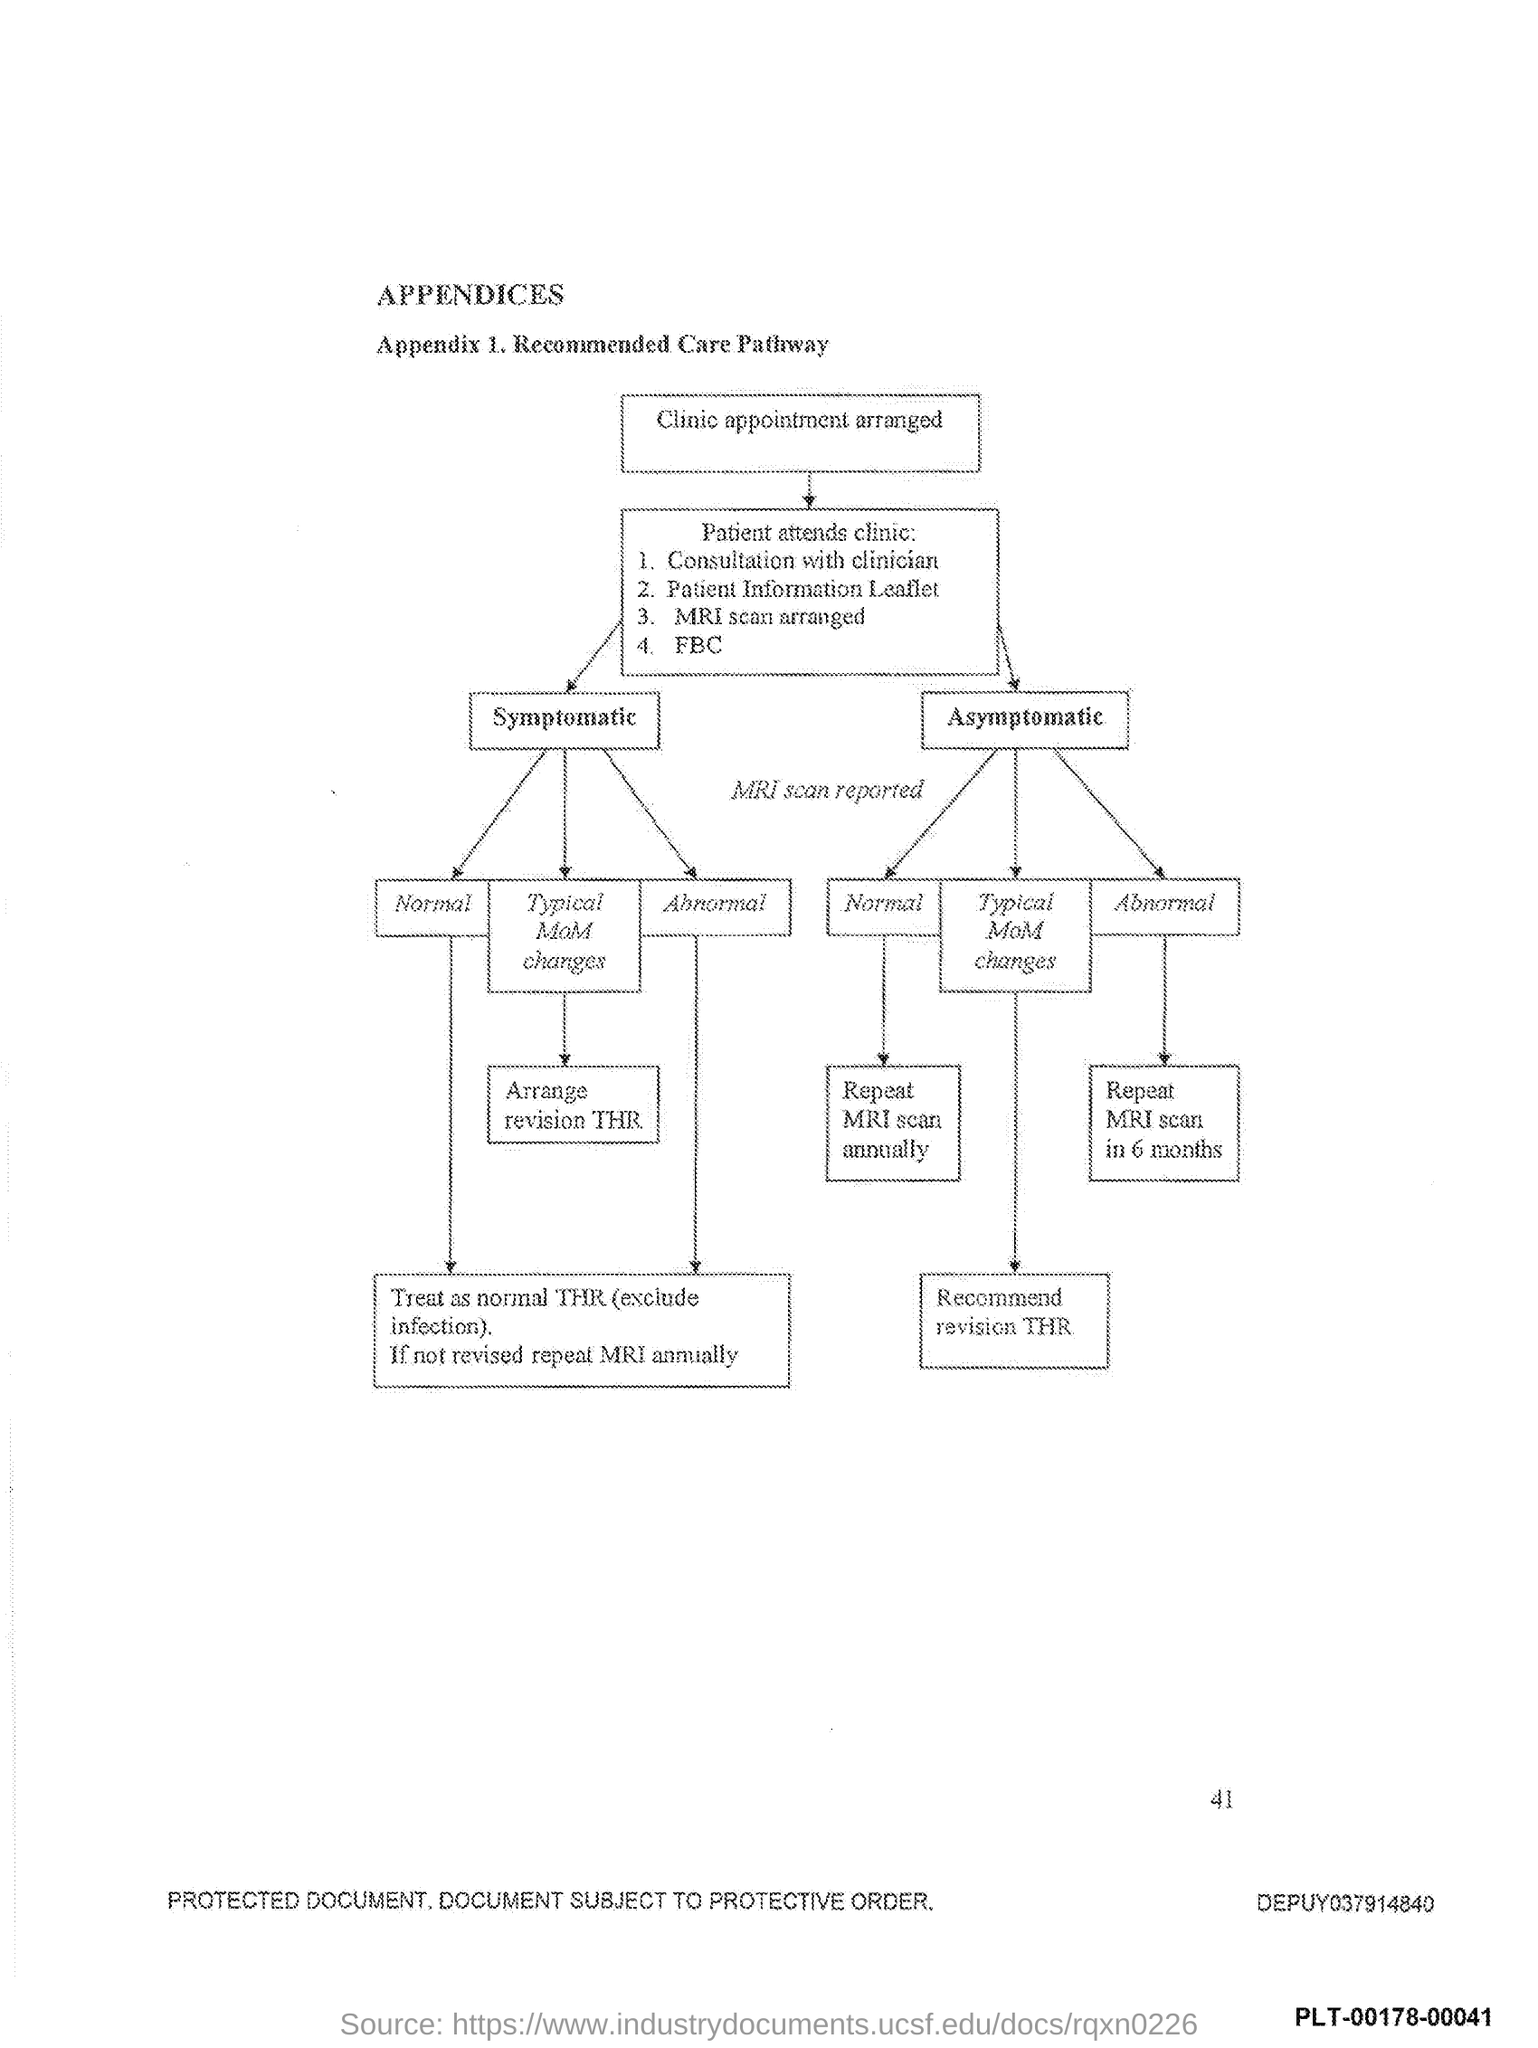What is the number at bottom right side of the page?
Your response must be concise. 41. 